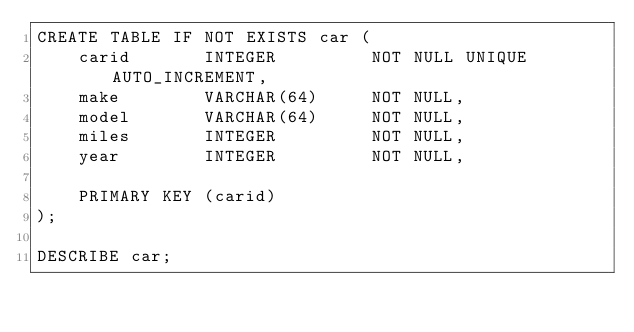Convert code to text. <code><loc_0><loc_0><loc_500><loc_500><_SQL_>CREATE TABLE IF NOT EXISTS car (
    carid       INTEGER         NOT NULL UNIQUE AUTO_INCREMENT,
    make        VARCHAR(64)     NOT NULL,
    model       VARCHAR(64)     NOT NULL,
    miles       INTEGER         NOT NULL,
    year        INTEGER         NOT NULL,
    
    PRIMARY KEY (carid)
);

DESCRIBE car;</code> 